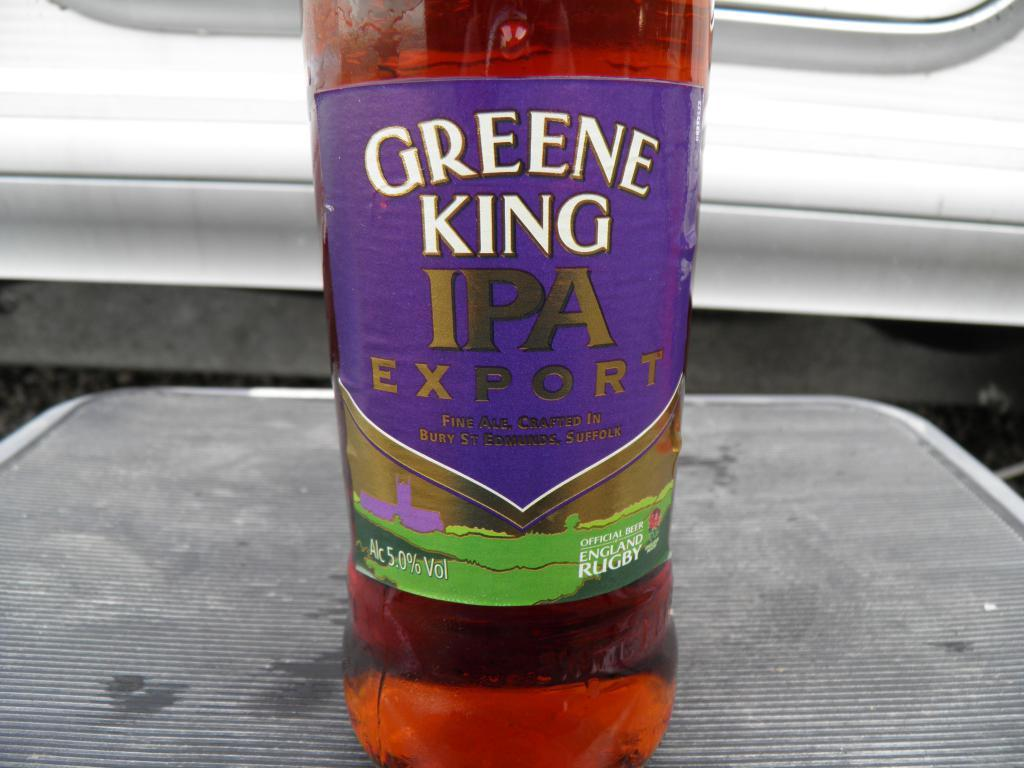<image>
Describe the image concisely. A red bottle with a purple label that reads Greene King IPA Export. 